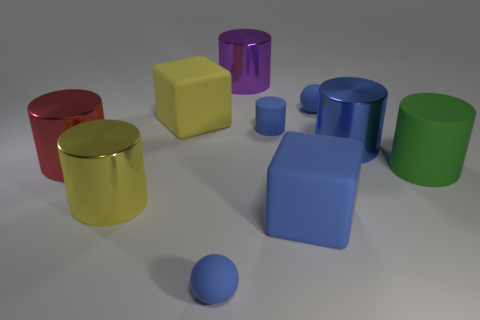Subtract all green cylinders. How many cylinders are left? 5 Subtract 2 spheres. How many spheres are left? 0 Subtract all brown cylinders. How many red spheres are left? 0 Subtract all purple cylinders. How many cylinders are left? 5 Subtract 0 green spheres. How many objects are left? 10 Subtract all blocks. How many objects are left? 8 Subtract all red cylinders. Subtract all green blocks. How many cylinders are left? 5 Subtract all blue matte balls. Subtract all large blue metal objects. How many objects are left? 7 Add 7 large green matte cylinders. How many large green matte cylinders are left? 8 Add 1 small purple objects. How many small purple objects exist? 1 